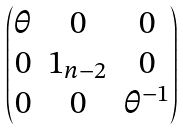<formula> <loc_0><loc_0><loc_500><loc_500>\begin{pmatrix} \theta & 0 & 0 \\ 0 & 1 _ { n - 2 } & 0 \\ 0 & 0 & \theta ^ { - 1 } \end{pmatrix}</formula> 